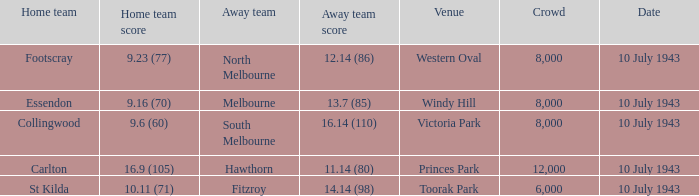When the carlton's home team competed, what was their score? 16.9 (105). 